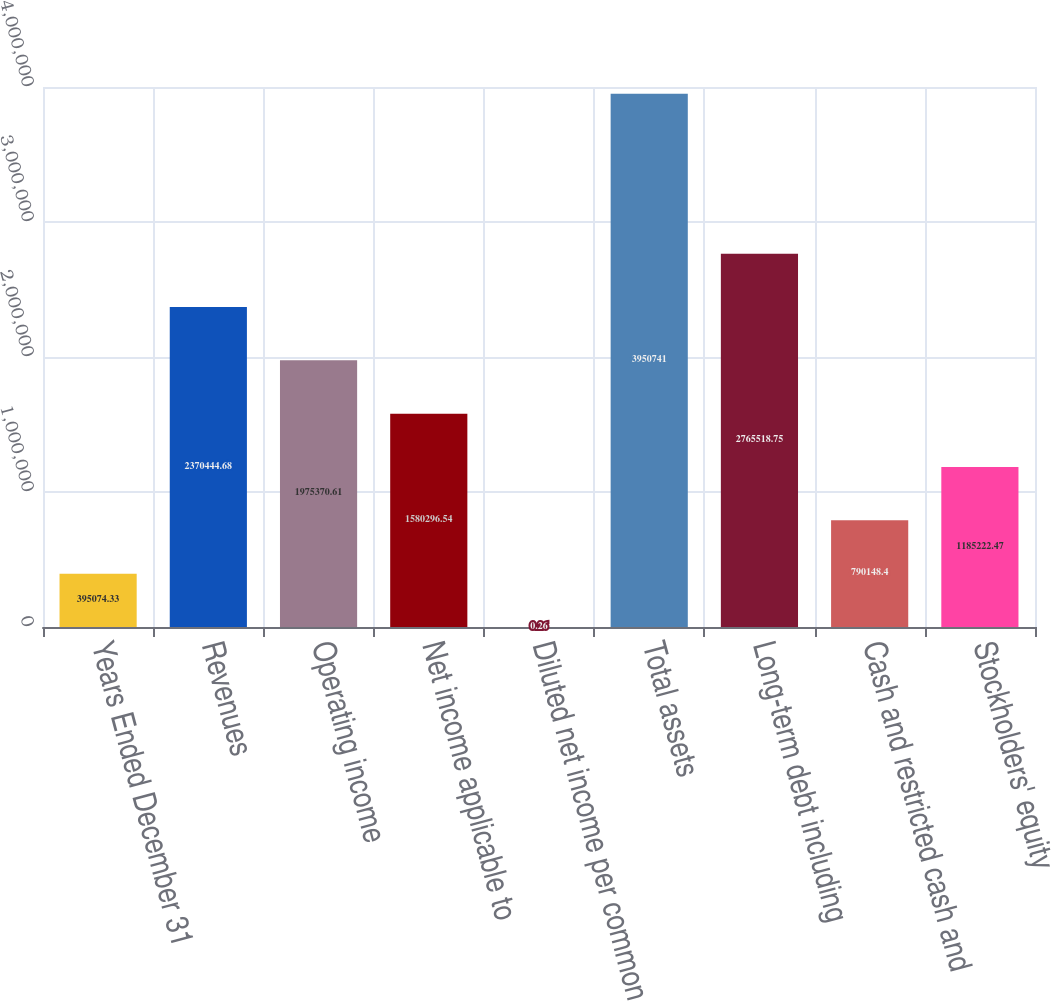<chart> <loc_0><loc_0><loc_500><loc_500><bar_chart><fcel>Years Ended December 31<fcel>Revenues<fcel>Operating income<fcel>Net income applicable to<fcel>Diluted net income per common<fcel>Total assets<fcel>Long-term debt including<fcel>Cash and restricted cash and<fcel>Stockholders' equity<nl><fcel>395074<fcel>2.37044e+06<fcel>1.97537e+06<fcel>1.5803e+06<fcel>0.26<fcel>3.95074e+06<fcel>2.76552e+06<fcel>790148<fcel>1.18522e+06<nl></chart> 